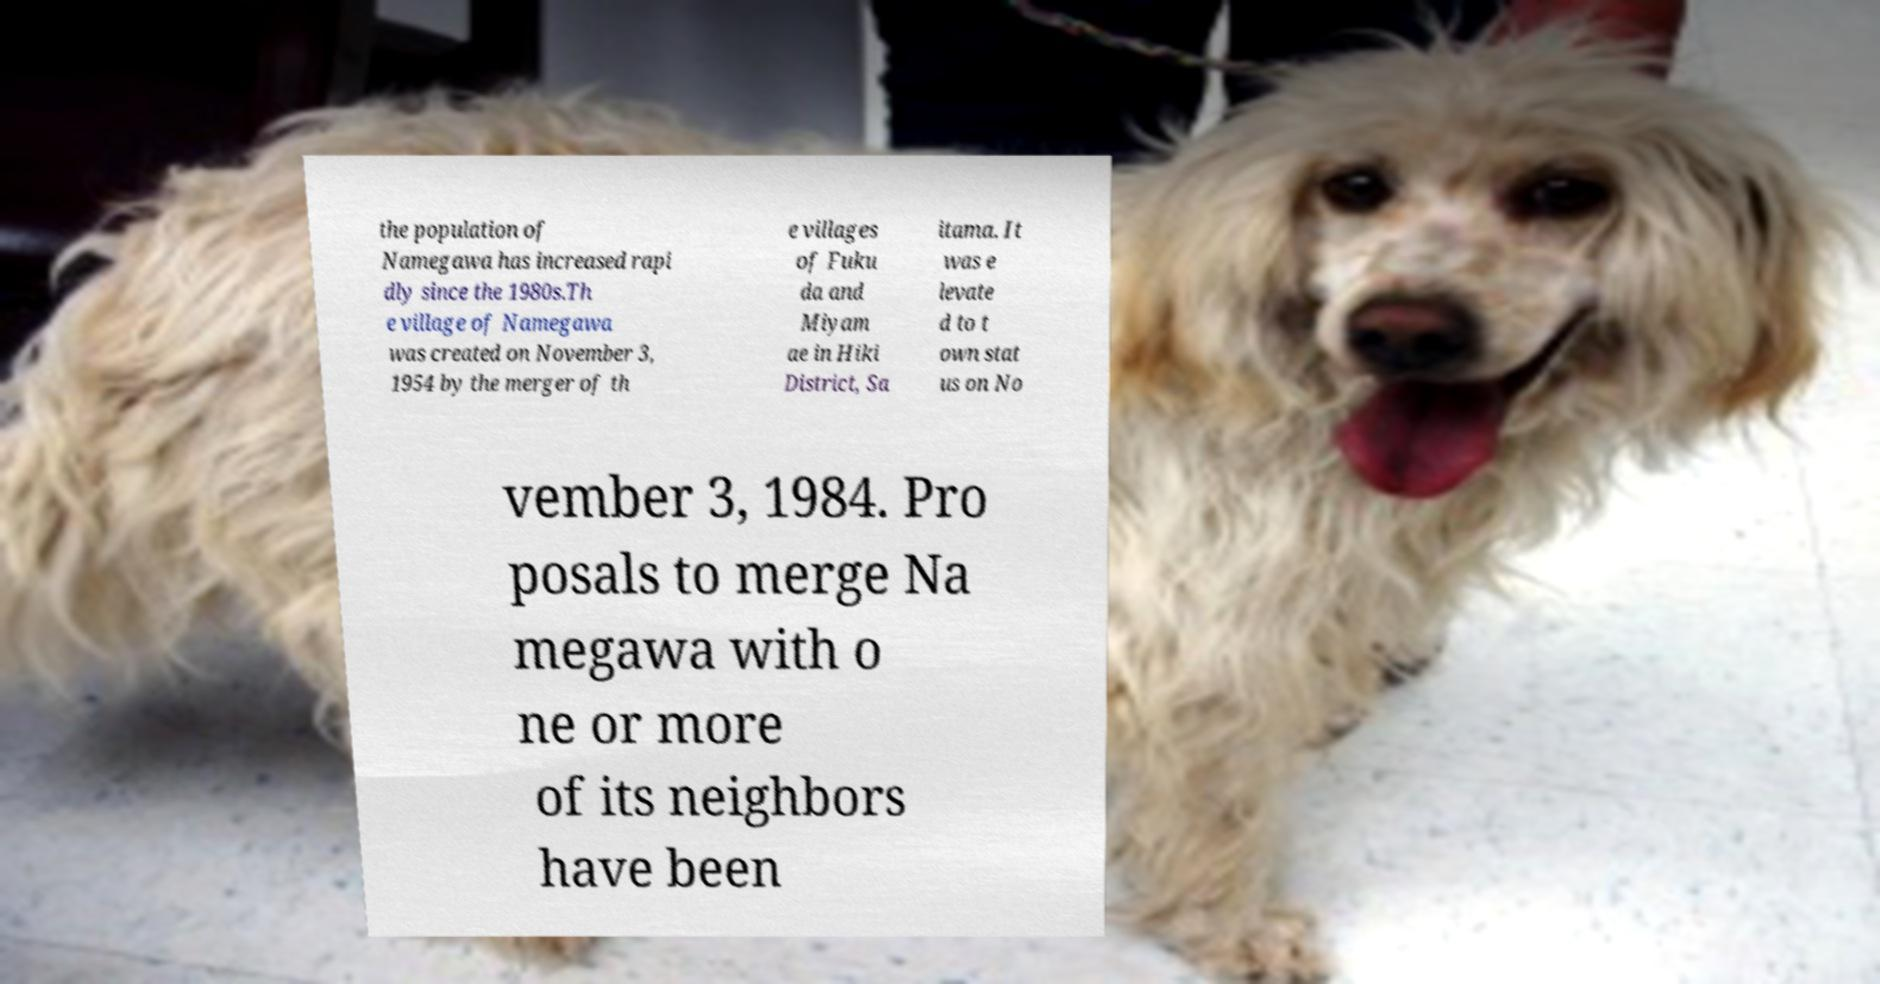Please identify and transcribe the text found in this image. the population of Namegawa has increased rapi dly since the 1980s.Th e village of Namegawa was created on November 3, 1954 by the merger of th e villages of Fuku da and Miyam ae in Hiki District, Sa itama. It was e levate d to t own stat us on No vember 3, 1984. Pro posals to merge Na megawa with o ne or more of its neighbors have been 